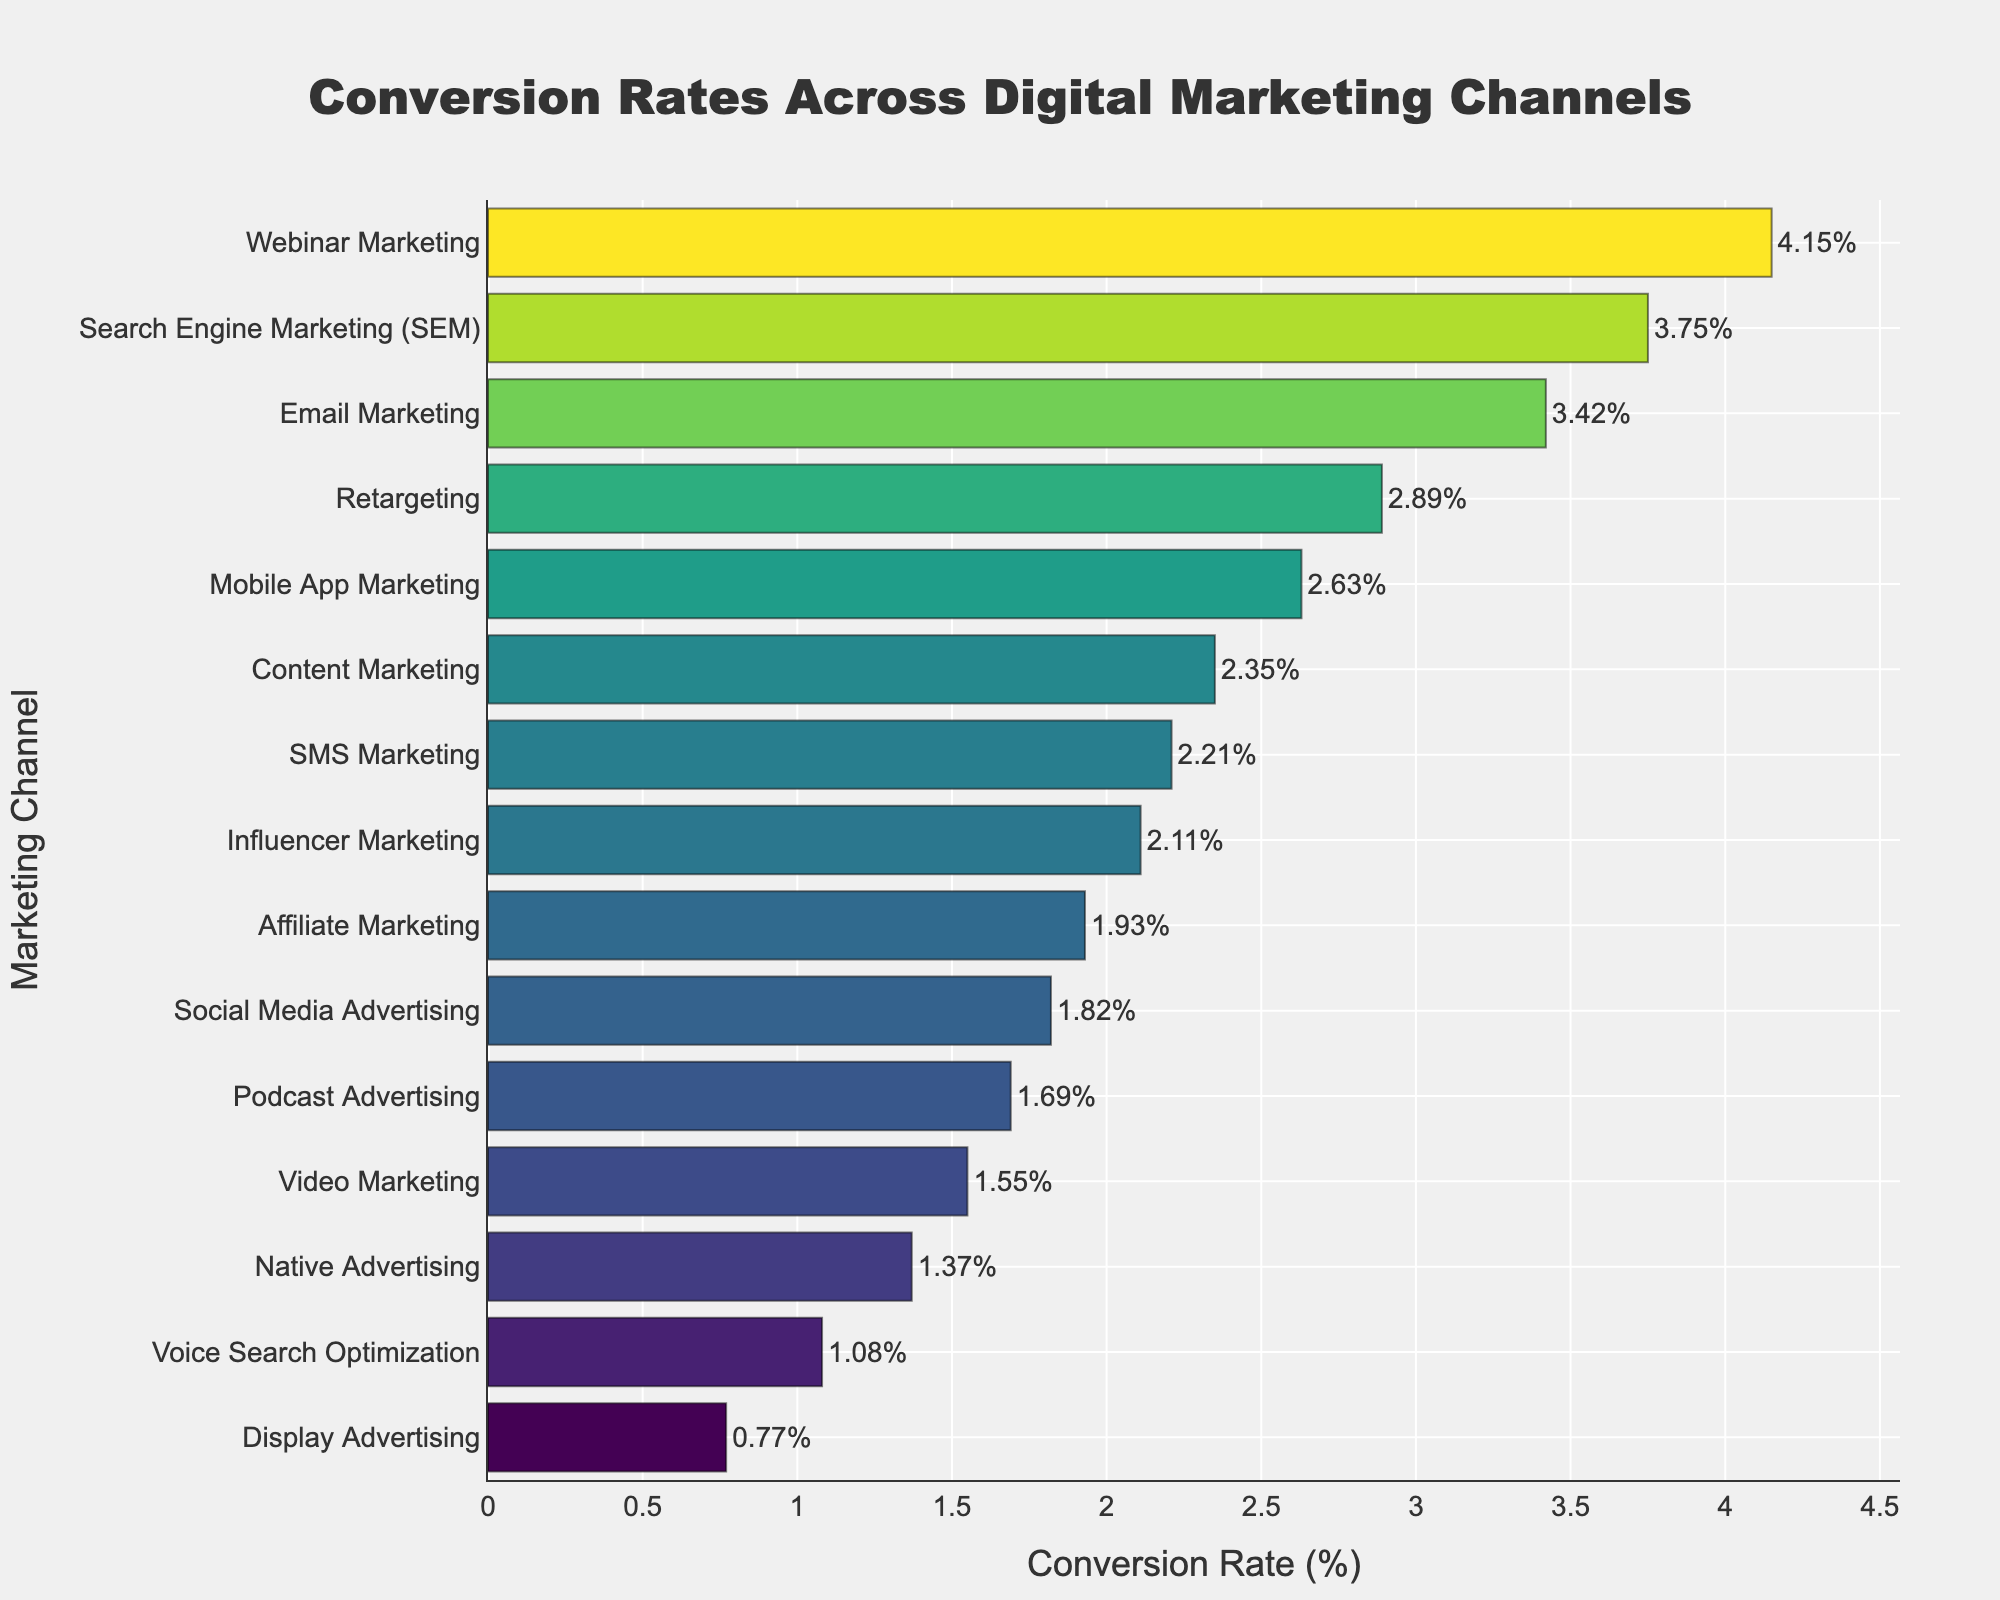What's the highest conversion rate shown for any marketing channel? We look at the bar that extends the furthest to the right for the highest conversion rate. "Webinar Marketing" has the longest bar which indicates it's the highest.
Answer: Webinar Marketing Which marketing channel has the lowest conversion rate? We look at the shortest bar to identify the lowest conversion rate. "Display Advertising" has the shortest bar with the smallest value.
Answer: Display Advertising How does the conversion rate of Email Marketing compare to that of Mobile App Marketing? By comparing the lengths of the bars for "Email Marketing" and "Mobile App Marketing", we observe that "Email Marketing" (3.42%) has a slightly higher conversion rate than "Mobile App Marketing" (2.63%).
Answer: Email Marketing has a higher conversion rate What's the difference in conversion rates between the highest and lowest channels? The difference is calculated by subtracting the lowest conversion rate (0.77% for Display Advertising) from the highest conversion rate (4.15% for Webinar Marketing).
Answer: 3.38% What is the total conversion rate for Social Media Advertising, Content Marketing, and Retargeting combined? Summing the conversion rates of Social Media Advertising (1.82%), Content Marketing (2.35%), and Retargeting (2.89%) gives the total.
Answer: 7.06% Which marketing channel has a conversion rate closest to the median value of all channels? To find the median, first list all conversion rates in ascending order and find the middle value. The closest to the median conversion rate here is Mobile App Marketing with 2.63%.
Answer: Mobile App Marketing Among the channels with conversion rates lower than 2%, which has the highest rate? Identify bars with conversion rates below 2% and compare them. "Social Media Advertising" has a rate of 1.82%, and it is the highest among those under 2%.
Answer: Social Media Advertising How many channels have conversion rates above 3%? Count the number of bars extending past the 3% mark: SEM (3.75%), Email Marketing (3.42%), Webinar Marketing (4.15%), and Retargeting (2.89%).
Answer: 4 channels What's the average conversion rate across all marketing channels? Sum all conversion rates and divide by the number of channels. The sum is 31.61% and there are 15 channels, so the average is 31.61/15.
Answer: 2.11% 